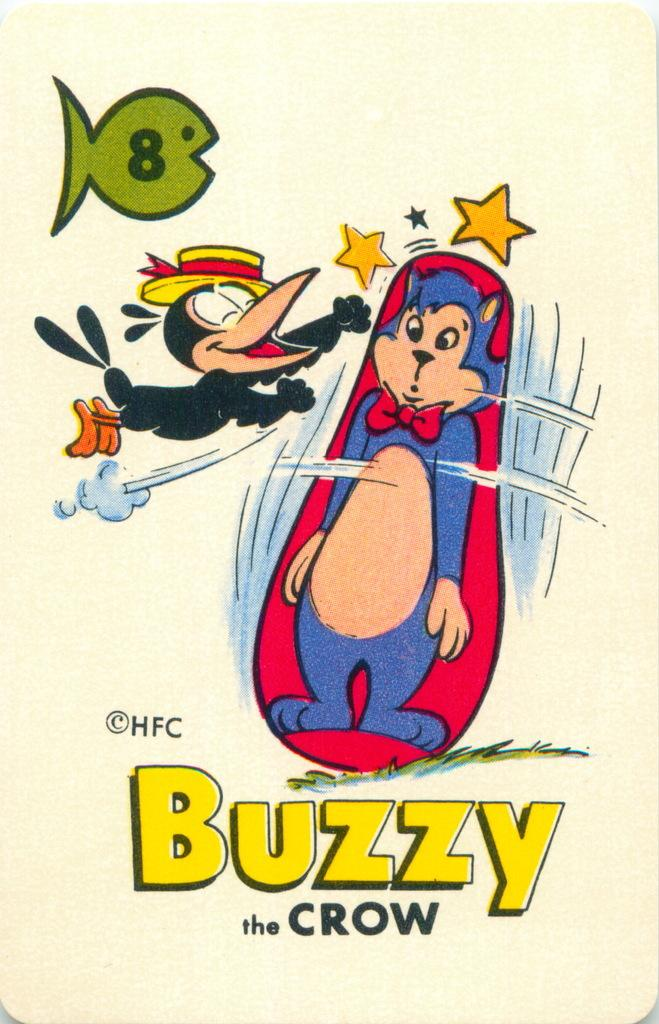<image>
Describe the image concisely. a Buzzy the Crow cartoon advert with a crow and a cat punching bag. 